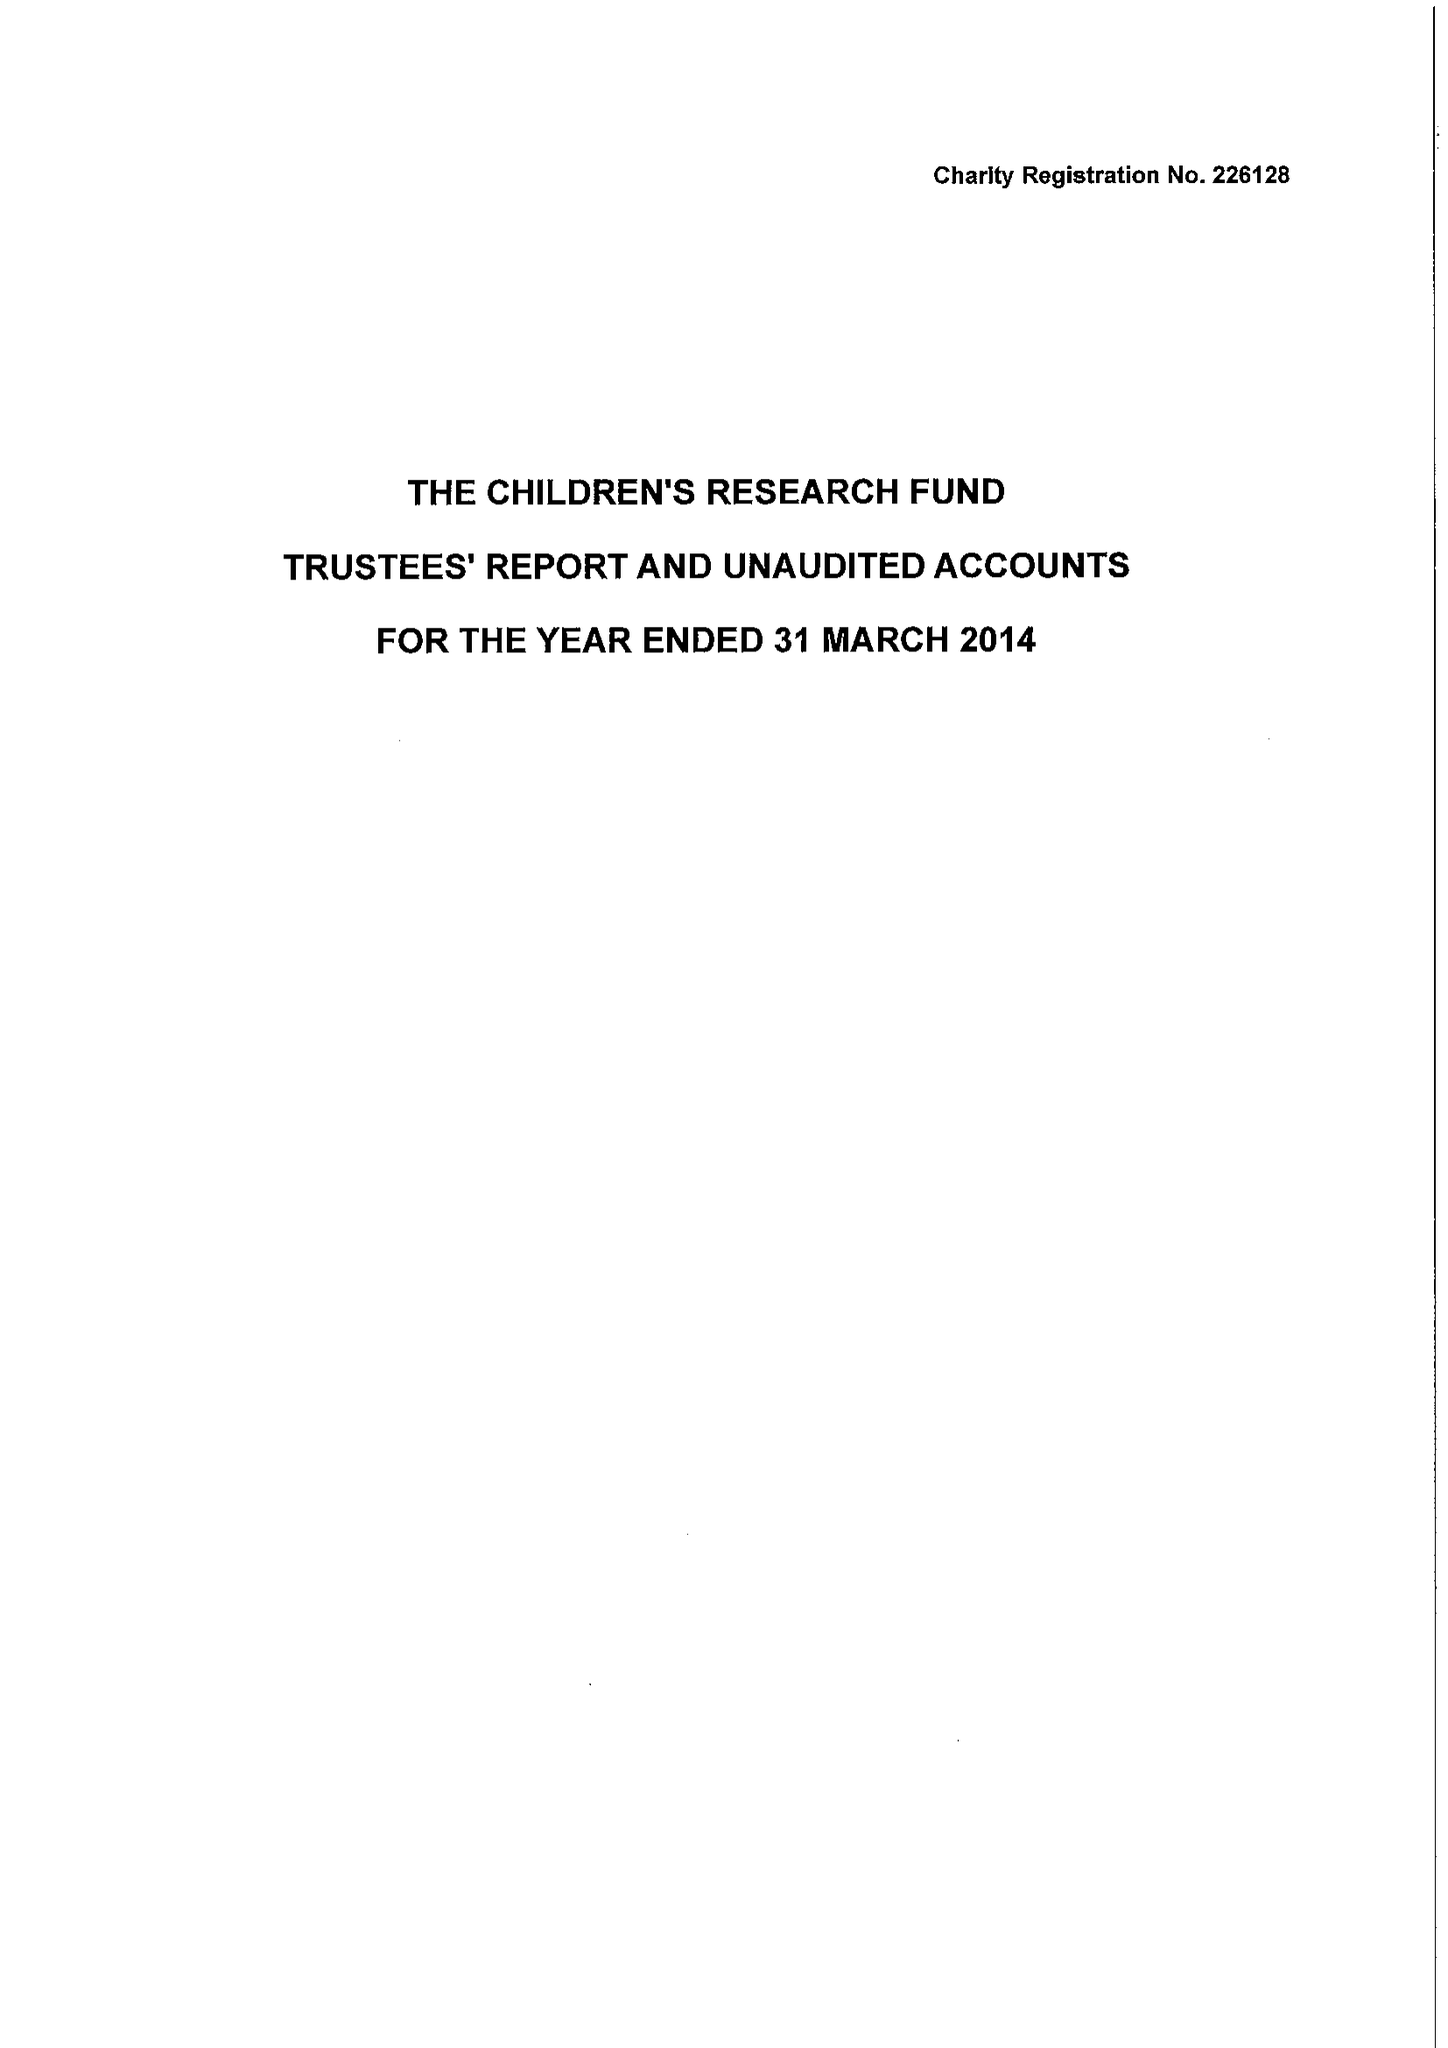What is the value for the address__post_town?
Answer the question using a single word or phrase. RUTHIN 